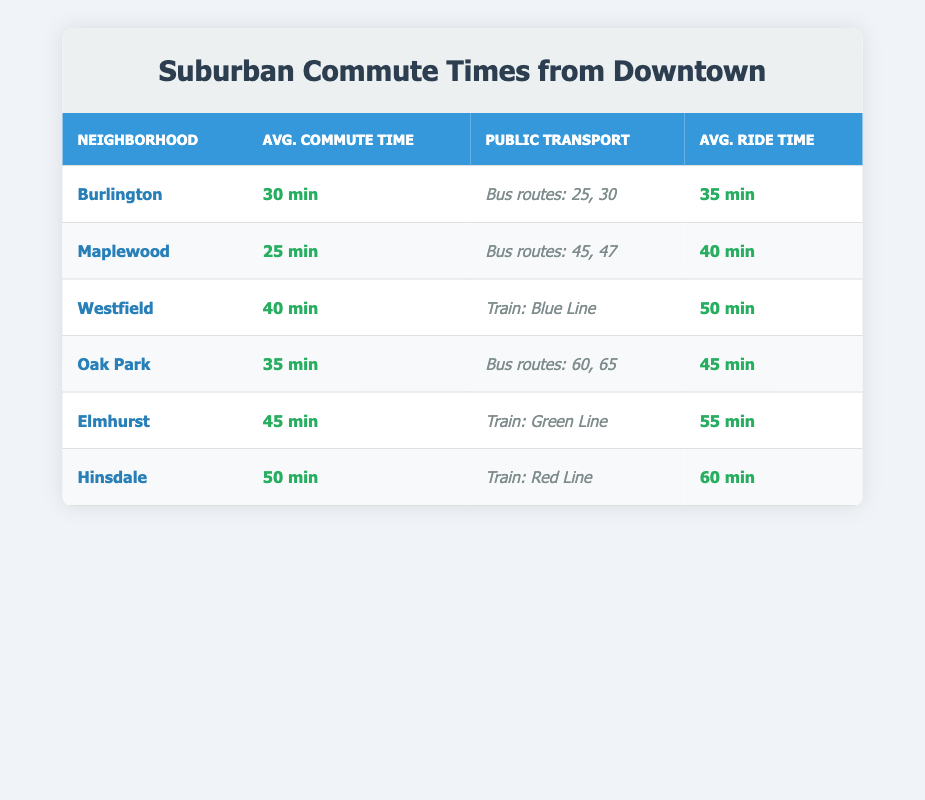What is the average commute time for Maplewood? The table lists the average commute time for Maplewood as 25 minutes.
Answer: 25 min Which suburban neighborhood has the longest average commute time? Hinsdale has the longest average commute time, which is 50 minutes, as indicated in the table.
Answer: Hinsdale How many bus routes serve Burlington? The table states that Burlington is served by bus routes 25 and 30, which means there are 2 routes in total.
Answer: 2 What is the difference in average commute times between Elmhurst and Maplewood? Elmhurst has an average commute time of 45 minutes, while Maplewood has an average of 25 minutes. The difference is 45 - 25 = 20 minutes.
Answer: 20 min Is it true that Westfield has a shorter commute time than Oak Park? Westfield's average commute time is 40 minutes, whereas Oak Park's is 35 minutes. Since 40 is greater than 35, the statement is false.
Answer: No What is the average ride time for the public transport in Burlington? The average ride time for public transport in Burlington is 35 minutes, according to the table.
Answer: 35 min If you were to combine the average commute times of Maplewood and Burlington, what would that total? The average commute time for Maplewood is 25 minutes and for Burlington is 30 minutes. Adding them together gives 25 + 30 = 55 minutes.
Answer: 55 min Which suburban neighborhood has the shortest public transport ride time? The shortest average ride time listed is 35 minutes for Burlington public transport.
Answer: Burlington What is the average commute time across all listed suburban neighborhoods? The average commute time is calculated by summing all the average times: 30 + 25 + 40 + 35 + 45 + 50 = 225 minutes. Then divide by the number of neighborhoods (6) to get the average: 225/6 = 37.5 minutes.
Answer: 37.5 min 